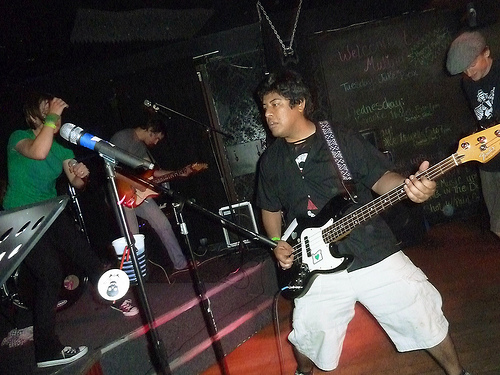<image>
Is there a guitar in front of the man? No. The guitar is not in front of the man. The spatial positioning shows a different relationship between these objects. 